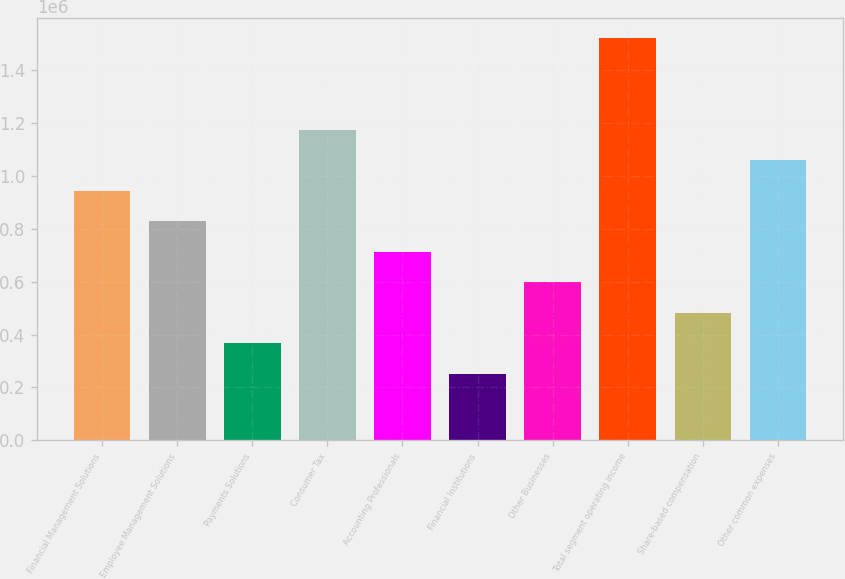<chart> <loc_0><loc_0><loc_500><loc_500><bar_chart><fcel>Financial Management Solutions<fcel>Employee Management Solutions<fcel>Payments Solutions<fcel>Consumer Tax<fcel>Accounting Professionals<fcel>Financial Institutions<fcel>Other Businesses<fcel>Total segment operating income<fcel>Share-based compensation<fcel>Other common expenses<nl><fcel>943894<fcel>828402<fcel>366438<fcel>1.17488e+06<fcel>712911<fcel>250946<fcel>597420<fcel>1.52135e+06<fcel>481929<fcel>1.05938e+06<nl></chart> 